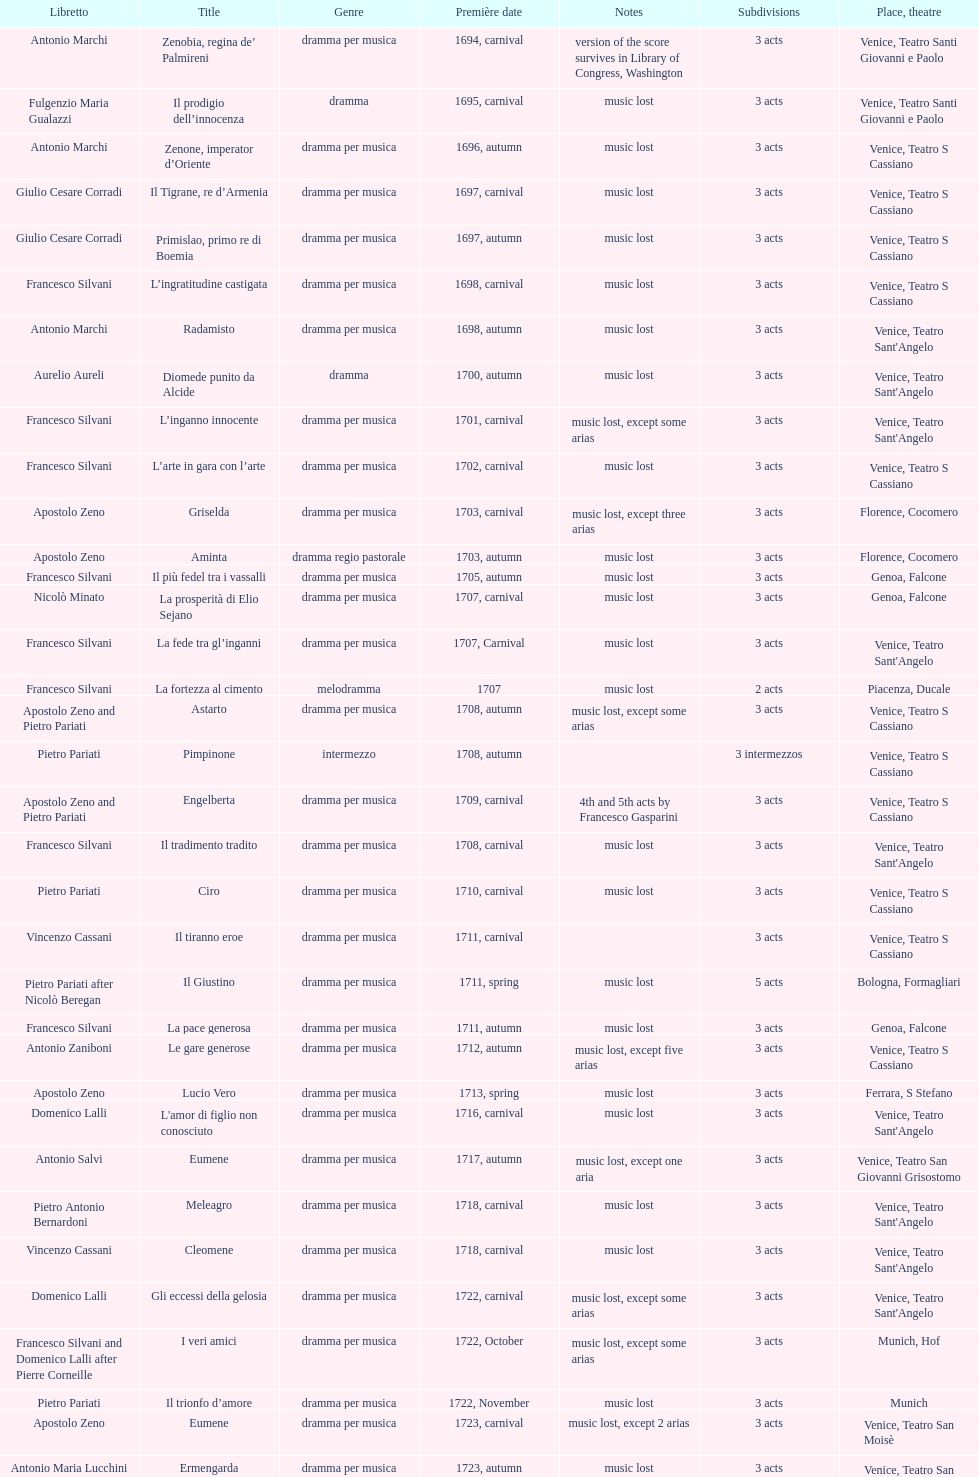Which title premiered directly after candalide? Artamene. 